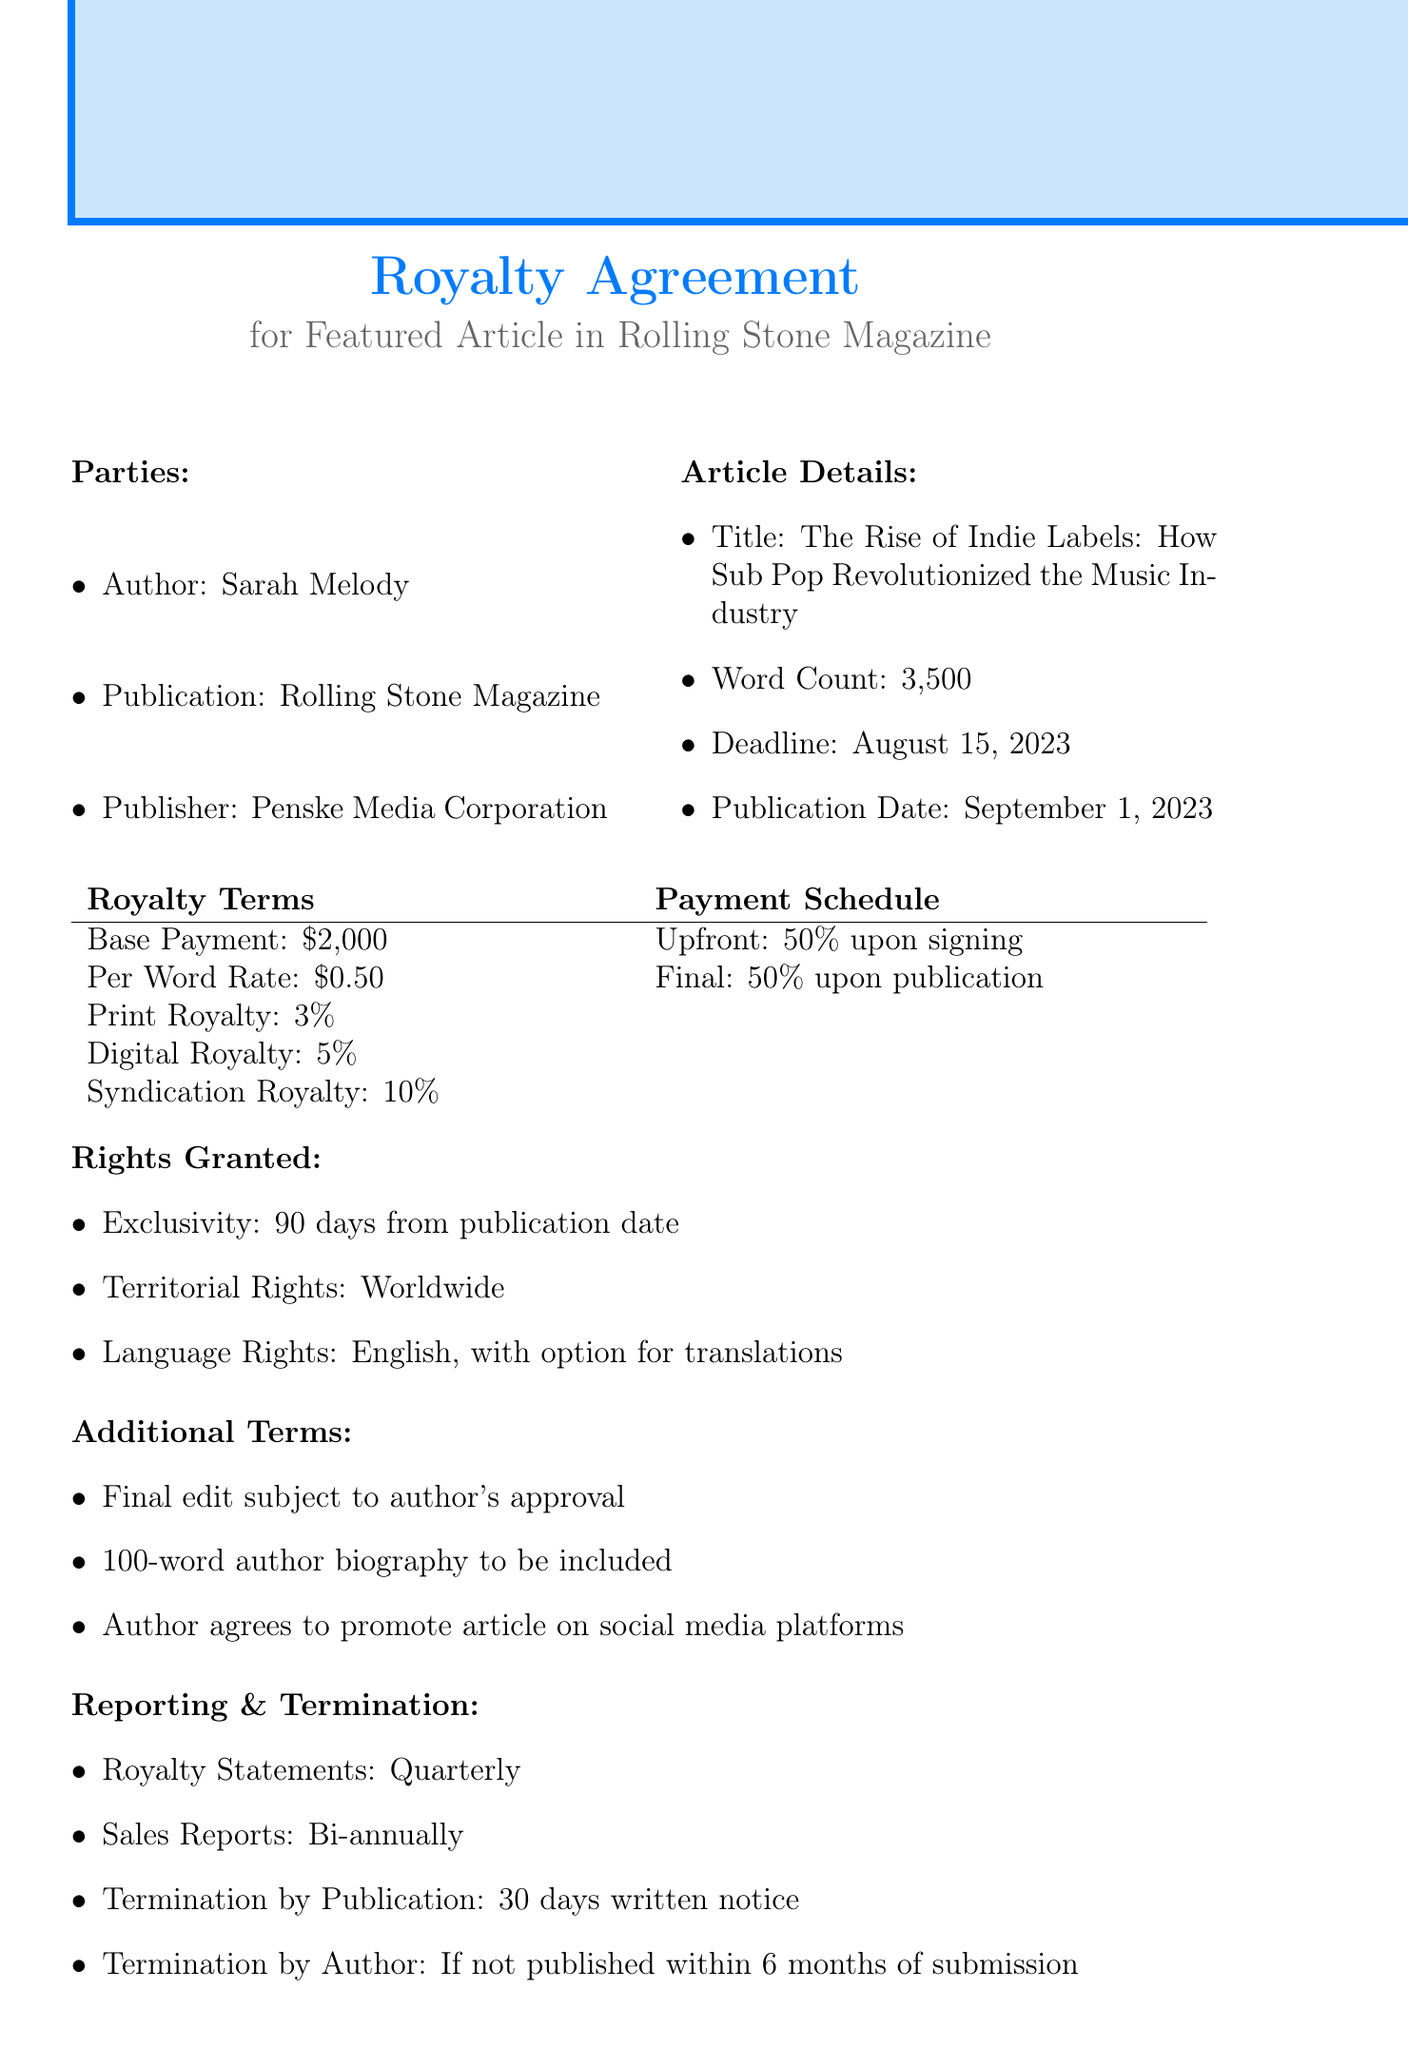What is the title of the article? The title is listed under article details, which is provided in the document.
Answer: The Rise of Indie Labels: How Sub Pop Revolutionized the Music Industry Who is the author of the article? The author is mentioned in the parties section of the contract document.
Answer: Sarah Melody When is the publication date? The publication date is clearly indicated in the article details section of the document.
Answer: September 1, 2023 What is the base payment amount? The base payment amount is specified in the royalty terms of the document.
Answer: $2000 What percentage is the digital royalty? The digital royalty percentage is stated in the royalty terms of the document.
Answer: 5% What happens if the article is not published within 6 months? The document specifies termination conditions in case of delays in publication.
Answer: Author may terminate What is included in the author's promotional obligations? The obligations are detailed within the additional terms section of the document.
Answer: Promote article on social media platforms What is the frequency of royalty statements? The document states how often royalty statements are to be reported.
Answer: Quarterly What is the exclusivity period granted to the publication? The exclusivity period is mentioned under rights granted in the contract.
Answer: 90 days from publication date 